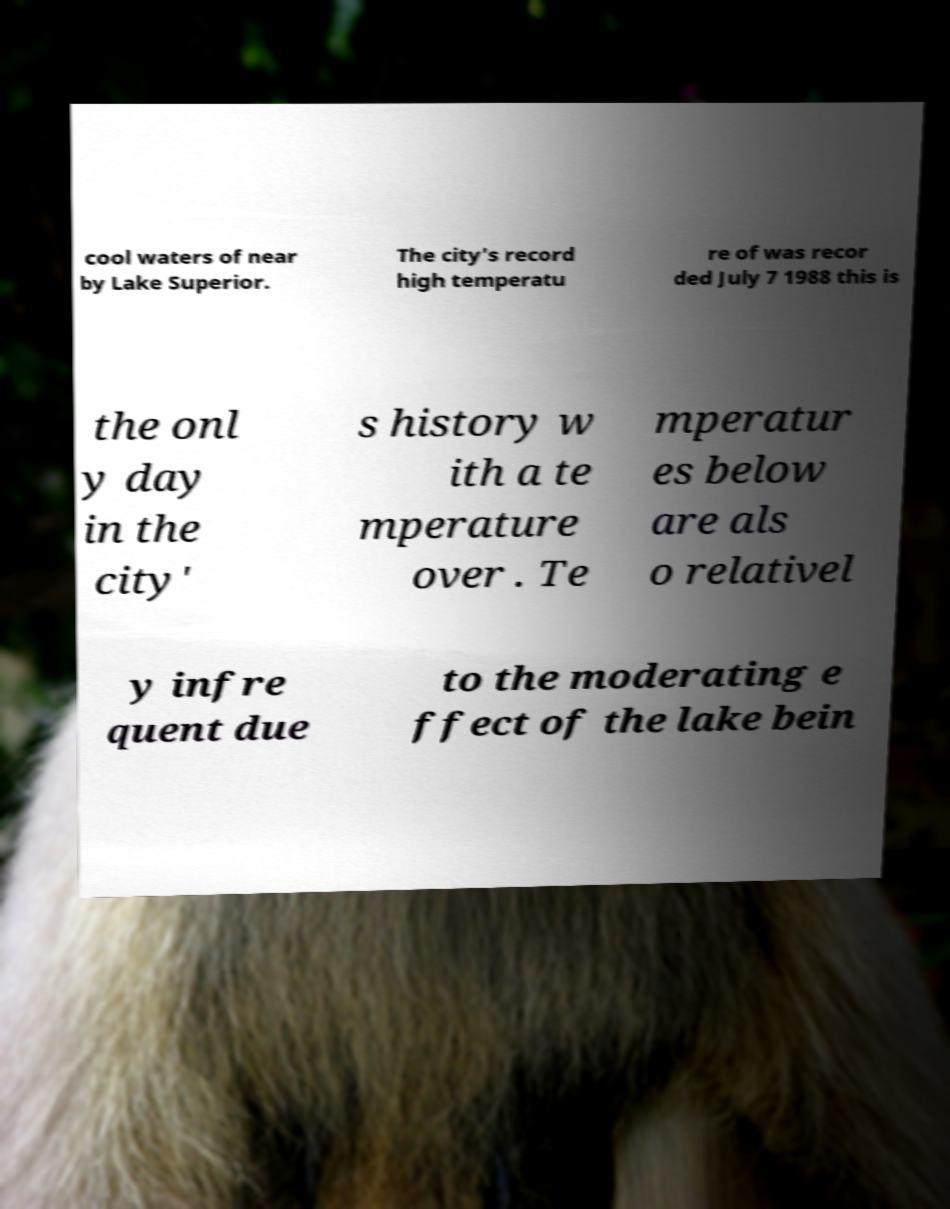Please read and relay the text visible in this image. What does it say? cool waters of near by Lake Superior. The city's record high temperatu re of was recor ded July 7 1988 this is the onl y day in the city' s history w ith a te mperature over . Te mperatur es below are als o relativel y infre quent due to the moderating e ffect of the lake bein 